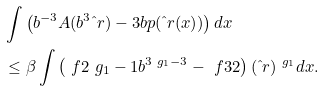<formula> <loc_0><loc_0><loc_500><loc_500>& \int \left ( b ^ { - 3 } A ( b ^ { 3 } \hat { \ } r ) - 3 b p ( \hat { \ } r ( x ) ) \right ) d x \\ & \leq \beta \int \left ( \ f { 2 } { \ g _ { 1 } - 1 } b ^ { 3 \ g _ { 1 } - 3 } - \ f { 3 } { 2 } \right ) ( \hat { \ } r ) ^ { \ g _ { 1 } } d x .</formula> 